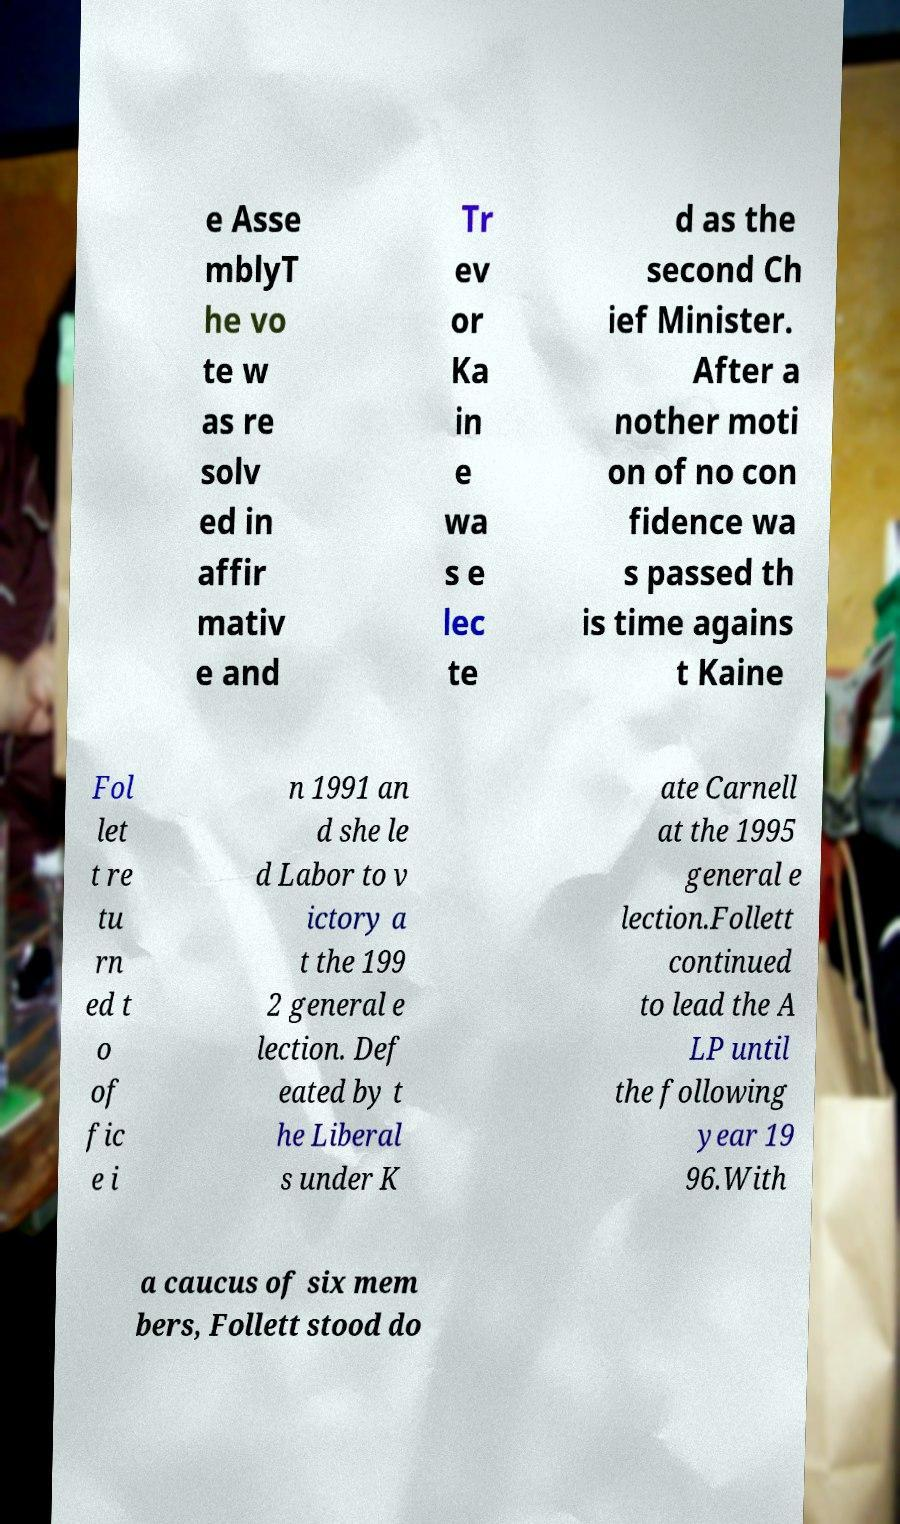Can you accurately transcribe the text from the provided image for me? e Asse mblyT he vo te w as re solv ed in affir mativ e and Tr ev or Ka in e wa s e lec te d as the second Ch ief Minister. After a nother moti on of no con fidence wa s passed th is time agains t Kaine Fol let t re tu rn ed t o of fic e i n 1991 an d she le d Labor to v ictory a t the 199 2 general e lection. Def eated by t he Liberal s under K ate Carnell at the 1995 general e lection.Follett continued to lead the A LP until the following year 19 96.With a caucus of six mem bers, Follett stood do 